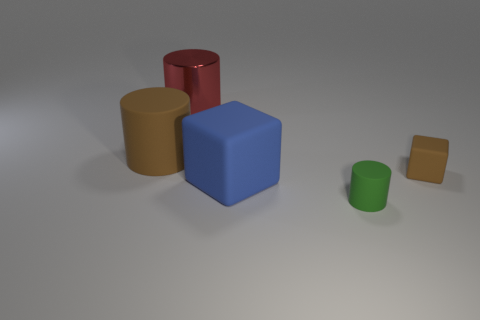There is a rubber thing that is the same color as the large matte cylinder; what shape is it?
Your answer should be very brief. Cube. Is the color of the tiny cube the same as the big matte cylinder?
Your response must be concise. Yes. Is there anything else that has the same material as the big red cylinder?
Your response must be concise. No. Do the rubber block on the right side of the green rubber thing and the tiny green object have the same size?
Your response must be concise. Yes. What number of other objects are the same shape as the small brown object?
Ensure brevity in your answer.  1. What number of brown objects are either cylinders or cubes?
Keep it short and to the point. 2. Does the large cylinder that is in front of the big red metal cylinder have the same color as the tiny rubber cube?
Your response must be concise. Yes. There is a brown object that is made of the same material as the brown cube; what is its shape?
Your response must be concise. Cylinder. There is a cylinder that is in front of the metal cylinder and to the left of the small cylinder; what is its color?
Your answer should be compact. Brown. There is a brown rubber object that is left of the rubber block left of the green object; what is its size?
Your response must be concise. Large. 